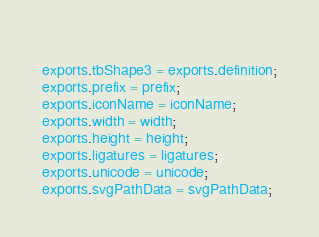<code> <loc_0><loc_0><loc_500><loc_500><_JavaScript_>	
exports.tbShape3 = exports.definition;
exports.prefix = prefix;
exports.iconName = iconName;
exports.width = width;
exports.height = height;
exports.ligatures = ligatures;
exports.unicode = unicode;
exports.svgPathData = svgPathData;</code> 